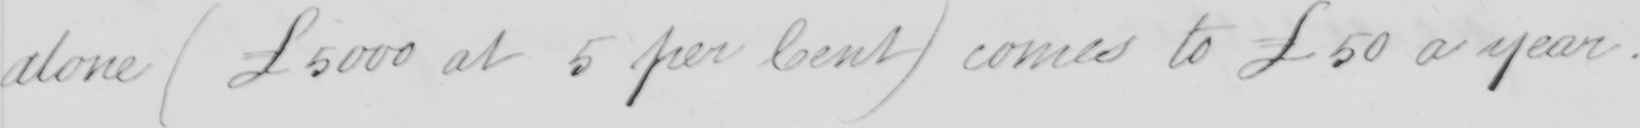What text is written in this handwritten line? alone (£5000 at 5 per Cent) comes to £50 a year. 